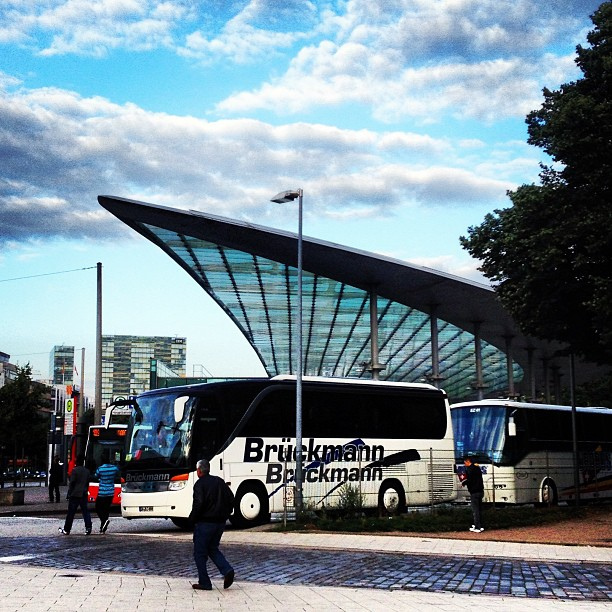Please transcribe the text in this image. Bruckmann Brickmann 